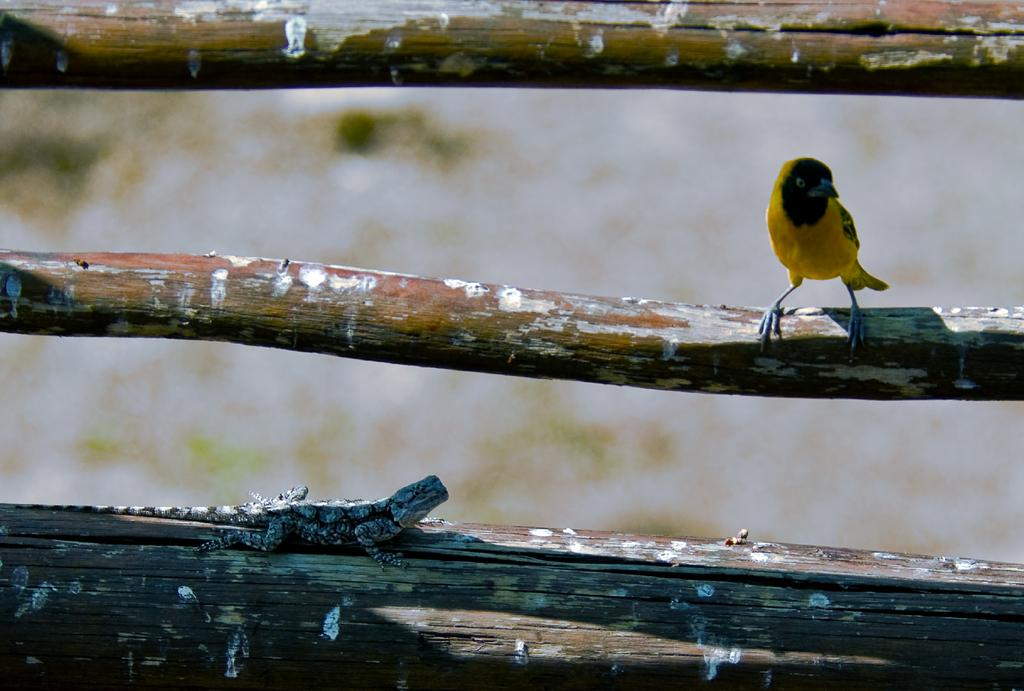What type of animal can be seen on the fence in the image? There is a bird on the fence on the right side of the image. What other creature can be found at the bottom of the image? There is a garden lizard at the bottom of the image. What type of cake is being served at the airport in the image? There is no cake or airport present in the image; it features a bird on a fence and a garden lizard. What story is being told by the characters in the image? There are no characters or story depicted in the image; it only shows a bird and a garden lizard. 